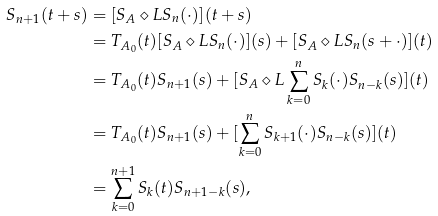<formula> <loc_0><loc_0><loc_500><loc_500>S _ { n + 1 } ( t + s ) & = [ S _ { A } \diamond L S _ { n } ( \cdot ) ] ( t + s ) \\ & = T _ { A _ { 0 } } ( t ) [ S _ { A } \diamond L S _ { n } ( \cdot ) ] ( s ) + [ S _ { A } \diamond L S _ { n } ( s + \cdot ) ] ( t ) \quad \\ & = T _ { A _ { 0 } } ( t ) S _ { n + 1 } ( s ) + [ S _ { A } \diamond L \sum _ { k = 0 } ^ { n } S _ { k } ( \cdot ) S _ { n - k } ( s ) ] ( t ) \quad \\ & = T _ { A _ { 0 } } ( t ) S _ { n + 1 } ( s ) + [ \sum _ { k = 0 } ^ { n } S _ { k + 1 } ( \cdot ) S _ { n - k } ( s ) ] ( t ) \\ & = \sum _ { k = 0 } ^ { n + 1 } S _ { k } ( t ) S _ { n + 1 - k } ( s ) ,</formula> 